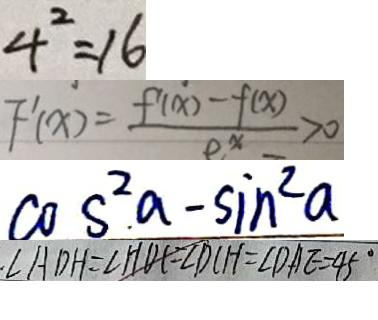Convert formula to latex. <formula><loc_0><loc_0><loc_500><loc_500>4 ^ { 2 } = 1 6 
 F ^ { \prime } ( x ) = \frac { f ( x ) - f ( x ) } { e ^ { x } } > 0 
 \cos ^ { 2 } . a - \sin ^ { 2 } a 
 \angle A D H = \angle H D C = \angle D C H = \angle D A E = 4 5 ^ { \circ }</formula> 